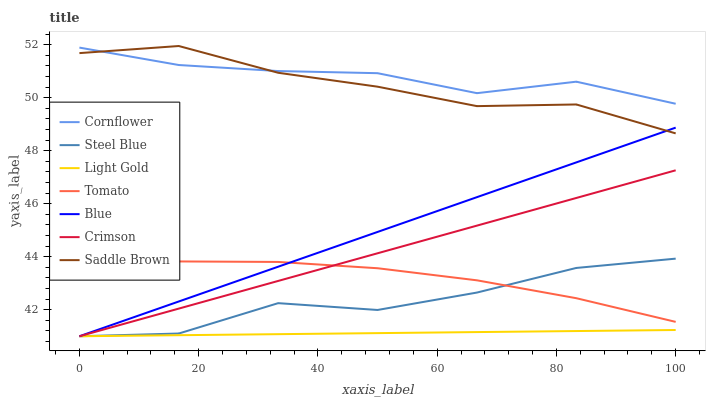Does Steel Blue have the minimum area under the curve?
Answer yes or no. No. Does Steel Blue have the maximum area under the curve?
Answer yes or no. No. Is Cornflower the smoothest?
Answer yes or no. No. Is Cornflower the roughest?
Answer yes or no. No. Does Cornflower have the lowest value?
Answer yes or no. No. Does Cornflower have the highest value?
Answer yes or no. No. Is Tomato less than Saddle Brown?
Answer yes or no. Yes. Is Cornflower greater than Blue?
Answer yes or no. Yes. Does Tomato intersect Saddle Brown?
Answer yes or no. No. 